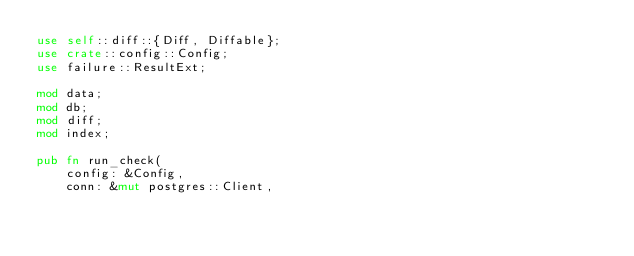Convert code to text. <code><loc_0><loc_0><loc_500><loc_500><_Rust_>use self::diff::{Diff, Diffable};
use crate::config::Config;
use failure::ResultExt;

mod data;
mod db;
mod diff;
mod index;

pub fn run_check(
    config: &Config,
    conn: &mut postgres::Client,</code> 